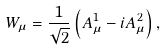Convert formula to latex. <formula><loc_0><loc_0><loc_500><loc_500>W _ { \mu } = \frac { 1 } { \sqrt { 2 } } \left ( A _ { \mu } ^ { 1 } - i A _ { \mu } ^ { 2 } \right ) ,</formula> 